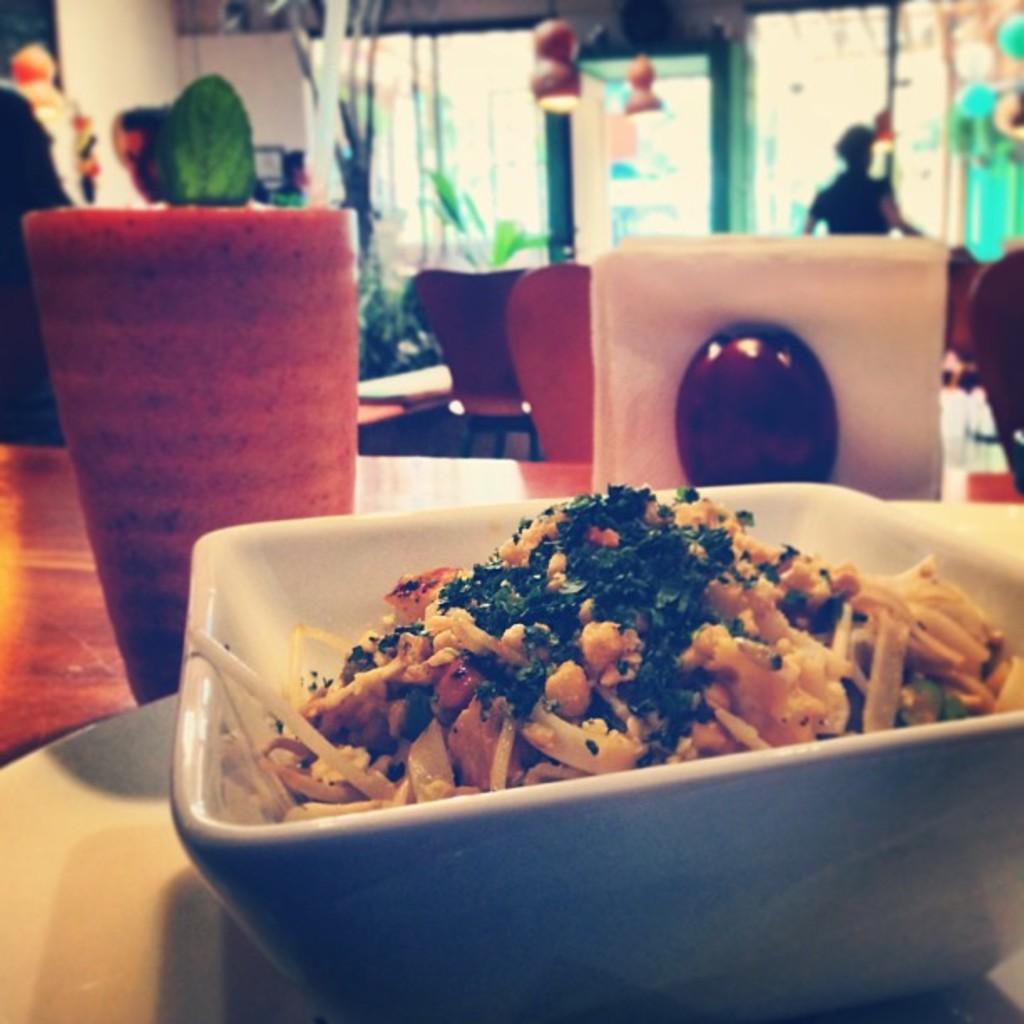Could you give a brief overview of what you see in this image? In this picture we can see a bowl with food in it, plate, glass and these all are placed on a table, chairs, person standing, plants and some objects and in the background we can see the wall. 